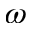Convert formula to latex. <formula><loc_0><loc_0><loc_500><loc_500>\omega</formula> 